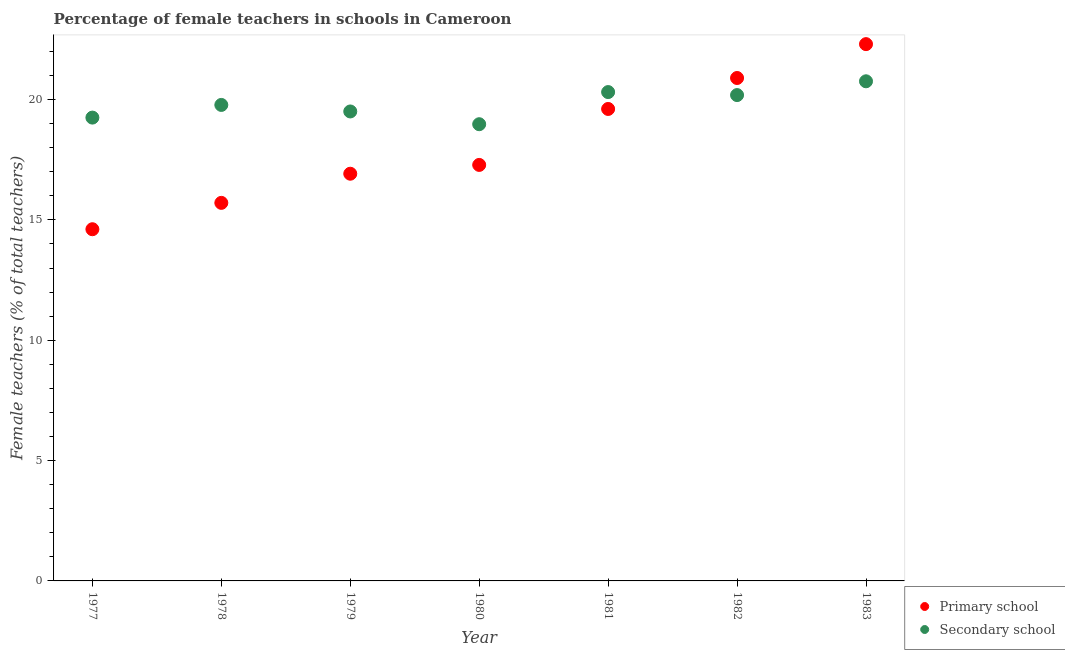How many different coloured dotlines are there?
Provide a short and direct response. 2. Is the number of dotlines equal to the number of legend labels?
Ensure brevity in your answer.  Yes. What is the percentage of female teachers in secondary schools in 1980?
Give a very brief answer. 18.98. Across all years, what is the maximum percentage of female teachers in secondary schools?
Provide a succinct answer. 20.76. Across all years, what is the minimum percentage of female teachers in primary schools?
Your answer should be compact. 14.61. What is the total percentage of female teachers in primary schools in the graph?
Offer a very short reply. 127.33. What is the difference between the percentage of female teachers in primary schools in 1977 and that in 1981?
Give a very brief answer. -5. What is the difference between the percentage of female teachers in primary schools in 1979 and the percentage of female teachers in secondary schools in 1978?
Your answer should be very brief. -2.86. What is the average percentage of female teachers in primary schools per year?
Offer a very short reply. 18.19. In the year 1978, what is the difference between the percentage of female teachers in primary schools and percentage of female teachers in secondary schools?
Make the answer very short. -4.07. In how many years, is the percentage of female teachers in primary schools greater than 7 %?
Offer a terse response. 7. What is the ratio of the percentage of female teachers in primary schools in 1978 to that in 1980?
Offer a terse response. 0.91. Is the percentage of female teachers in secondary schools in 1977 less than that in 1981?
Make the answer very short. Yes. Is the difference between the percentage of female teachers in primary schools in 1980 and 1982 greater than the difference between the percentage of female teachers in secondary schools in 1980 and 1982?
Make the answer very short. No. What is the difference between the highest and the second highest percentage of female teachers in secondary schools?
Ensure brevity in your answer.  0.45. What is the difference between the highest and the lowest percentage of female teachers in secondary schools?
Your response must be concise. 1.78. Is the sum of the percentage of female teachers in secondary schools in 1977 and 1980 greater than the maximum percentage of female teachers in primary schools across all years?
Keep it short and to the point. Yes. Is the percentage of female teachers in secondary schools strictly greater than the percentage of female teachers in primary schools over the years?
Ensure brevity in your answer.  No. Are the values on the major ticks of Y-axis written in scientific E-notation?
Offer a terse response. No. Does the graph contain grids?
Offer a terse response. No. Where does the legend appear in the graph?
Keep it short and to the point. Bottom right. What is the title of the graph?
Your answer should be compact. Percentage of female teachers in schools in Cameroon. What is the label or title of the Y-axis?
Your response must be concise. Female teachers (% of total teachers). What is the Female teachers (% of total teachers) in Primary school in 1977?
Your response must be concise. 14.61. What is the Female teachers (% of total teachers) in Secondary school in 1977?
Make the answer very short. 19.25. What is the Female teachers (% of total teachers) of Primary school in 1978?
Provide a succinct answer. 15.71. What is the Female teachers (% of total teachers) of Secondary school in 1978?
Offer a very short reply. 19.78. What is the Female teachers (% of total teachers) in Primary school in 1979?
Keep it short and to the point. 16.92. What is the Female teachers (% of total teachers) in Secondary school in 1979?
Keep it short and to the point. 19.51. What is the Female teachers (% of total teachers) of Primary school in 1980?
Offer a very short reply. 17.28. What is the Female teachers (% of total teachers) of Secondary school in 1980?
Give a very brief answer. 18.98. What is the Female teachers (% of total teachers) in Primary school in 1981?
Provide a succinct answer. 19.61. What is the Female teachers (% of total teachers) of Secondary school in 1981?
Offer a terse response. 20.31. What is the Female teachers (% of total teachers) of Primary school in 1982?
Give a very brief answer. 20.9. What is the Female teachers (% of total teachers) in Secondary school in 1982?
Your answer should be very brief. 20.19. What is the Female teachers (% of total teachers) in Primary school in 1983?
Offer a terse response. 22.3. What is the Female teachers (% of total teachers) in Secondary school in 1983?
Offer a very short reply. 20.76. Across all years, what is the maximum Female teachers (% of total teachers) of Primary school?
Give a very brief answer. 22.3. Across all years, what is the maximum Female teachers (% of total teachers) in Secondary school?
Provide a succinct answer. 20.76. Across all years, what is the minimum Female teachers (% of total teachers) of Primary school?
Your response must be concise. 14.61. Across all years, what is the minimum Female teachers (% of total teachers) of Secondary school?
Your answer should be very brief. 18.98. What is the total Female teachers (% of total teachers) of Primary school in the graph?
Provide a short and direct response. 127.33. What is the total Female teachers (% of total teachers) of Secondary school in the graph?
Give a very brief answer. 138.76. What is the difference between the Female teachers (% of total teachers) in Primary school in 1977 and that in 1978?
Ensure brevity in your answer.  -1.1. What is the difference between the Female teachers (% of total teachers) of Secondary school in 1977 and that in 1978?
Make the answer very short. -0.53. What is the difference between the Female teachers (% of total teachers) of Primary school in 1977 and that in 1979?
Keep it short and to the point. -2.31. What is the difference between the Female teachers (% of total teachers) of Secondary school in 1977 and that in 1979?
Offer a terse response. -0.26. What is the difference between the Female teachers (% of total teachers) of Primary school in 1977 and that in 1980?
Keep it short and to the point. -2.67. What is the difference between the Female teachers (% of total teachers) in Secondary school in 1977 and that in 1980?
Provide a succinct answer. 0.27. What is the difference between the Female teachers (% of total teachers) in Primary school in 1977 and that in 1981?
Offer a terse response. -5. What is the difference between the Female teachers (% of total teachers) in Secondary school in 1977 and that in 1981?
Your response must be concise. -1.06. What is the difference between the Female teachers (% of total teachers) in Primary school in 1977 and that in 1982?
Your answer should be compact. -6.28. What is the difference between the Female teachers (% of total teachers) of Secondary school in 1977 and that in 1982?
Your answer should be compact. -0.94. What is the difference between the Female teachers (% of total teachers) of Primary school in 1977 and that in 1983?
Offer a terse response. -7.69. What is the difference between the Female teachers (% of total teachers) of Secondary school in 1977 and that in 1983?
Your answer should be very brief. -1.51. What is the difference between the Female teachers (% of total teachers) in Primary school in 1978 and that in 1979?
Give a very brief answer. -1.21. What is the difference between the Female teachers (% of total teachers) of Secondary school in 1978 and that in 1979?
Your answer should be compact. 0.27. What is the difference between the Female teachers (% of total teachers) in Primary school in 1978 and that in 1980?
Give a very brief answer. -1.58. What is the difference between the Female teachers (% of total teachers) of Secondary school in 1978 and that in 1980?
Offer a terse response. 0.8. What is the difference between the Female teachers (% of total teachers) in Primary school in 1978 and that in 1981?
Make the answer very short. -3.9. What is the difference between the Female teachers (% of total teachers) of Secondary school in 1978 and that in 1981?
Your answer should be very brief. -0.53. What is the difference between the Female teachers (% of total teachers) of Primary school in 1978 and that in 1982?
Your answer should be compact. -5.19. What is the difference between the Female teachers (% of total teachers) in Secondary school in 1978 and that in 1982?
Ensure brevity in your answer.  -0.41. What is the difference between the Female teachers (% of total teachers) of Primary school in 1978 and that in 1983?
Provide a succinct answer. -6.6. What is the difference between the Female teachers (% of total teachers) of Secondary school in 1978 and that in 1983?
Your response must be concise. -0.98. What is the difference between the Female teachers (% of total teachers) of Primary school in 1979 and that in 1980?
Offer a very short reply. -0.37. What is the difference between the Female teachers (% of total teachers) in Secondary school in 1979 and that in 1980?
Make the answer very short. 0.53. What is the difference between the Female teachers (% of total teachers) of Primary school in 1979 and that in 1981?
Your answer should be very brief. -2.69. What is the difference between the Female teachers (% of total teachers) of Secondary school in 1979 and that in 1981?
Provide a succinct answer. -0.81. What is the difference between the Female teachers (% of total teachers) in Primary school in 1979 and that in 1982?
Offer a terse response. -3.98. What is the difference between the Female teachers (% of total teachers) of Secondary school in 1979 and that in 1982?
Offer a very short reply. -0.68. What is the difference between the Female teachers (% of total teachers) in Primary school in 1979 and that in 1983?
Offer a very short reply. -5.38. What is the difference between the Female teachers (% of total teachers) of Secondary school in 1979 and that in 1983?
Your answer should be very brief. -1.25. What is the difference between the Female teachers (% of total teachers) of Primary school in 1980 and that in 1981?
Your answer should be very brief. -2.33. What is the difference between the Female teachers (% of total teachers) of Secondary school in 1980 and that in 1981?
Your answer should be compact. -1.34. What is the difference between the Female teachers (% of total teachers) of Primary school in 1980 and that in 1982?
Offer a terse response. -3.61. What is the difference between the Female teachers (% of total teachers) of Secondary school in 1980 and that in 1982?
Keep it short and to the point. -1.21. What is the difference between the Female teachers (% of total teachers) of Primary school in 1980 and that in 1983?
Keep it short and to the point. -5.02. What is the difference between the Female teachers (% of total teachers) of Secondary school in 1980 and that in 1983?
Your response must be concise. -1.78. What is the difference between the Female teachers (% of total teachers) of Primary school in 1981 and that in 1982?
Your response must be concise. -1.29. What is the difference between the Female teachers (% of total teachers) of Secondary school in 1981 and that in 1982?
Ensure brevity in your answer.  0.12. What is the difference between the Female teachers (% of total teachers) of Primary school in 1981 and that in 1983?
Provide a succinct answer. -2.69. What is the difference between the Female teachers (% of total teachers) in Secondary school in 1981 and that in 1983?
Offer a terse response. -0.45. What is the difference between the Female teachers (% of total teachers) of Primary school in 1982 and that in 1983?
Keep it short and to the point. -1.41. What is the difference between the Female teachers (% of total teachers) in Secondary school in 1982 and that in 1983?
Provide a short and direct response. -0.57. What is the difference between the Female teachers (% of total teachers) in Primary school in 1977 and the Female teachers (% of total teachers) in Secondary school in 1978?
Keep it short and to the point. -5.16. What is the difference between the Female teachers (% of total teachers) of Primary school in 1977 and the Female teachers (% of total teachers) of Secondary school in 1979?
Provide a succinct answer. -4.89. What is the difference between the Female teachers (% of total teachers) in Primary school in 1977 and the Female teachers (% of total teachers) in Secondary school in 1980?
Offer a very short reply. -4.36. What is the difference between the Female teachers (% of total teachers) in Primary school in 1977 and the Female teachers (% of total teachers) in Secondary school in 1981?
Make the answer very short. -5.7. What is the difference between the Female teachers (% of total teachers) in Primary school in 1977 and the Female teachers (% of total teachers) in Secondary school in 1982?
Give a very brief answer. -5.57. What is the difference between the Female teachers (% of total teachers) of Primary school in 1977 and the Female teachers (% of total teachers) of Secondary school in 1983?
Offer a very short reply. -6.15. What is the difference between the Female teachers (% of total teachers) in Primary school in 1978 and the Female teachers (% of total teachers) in Secondary school in 1979?
Ensure brevity in your answer.  -3.8. What is the difference between the Female teachers (% of total teachers) in Primary school in 1978 and the Female teachers (% of total teachers) in Secondary school in 1980?
Your answer should be compact. -3.27. What is the difference between the Female teachers (% of total teachers) in Primary school in 1978 and the Female teachers (% of total teachers) in Secondary school in 1981?
Offer a terse response. -4.6. What is the difference between the Female teachers (% of total teachers) in Primary school in 1978 and the Female teachers (% of total teachers) in Secondary school in 1982?
Give a very brief answer. -4.48. What is the difference between the Female teachers (% of total teachers) of Primary school in 1978 and the Female teachers (% of total teachers) of Secondary school in 1983?
Your response must be concise. -5.05. What is the difference between the Female teachers (% of total teachers) in Primary school in 1979 and the Female teachers (% of total teachers) in Secondary school in 1980?
Provide a short and direct response. -2.06. What is the difference between the Female teachers (% of total teachers) in Primary school in 1979 and the Female teachers (% of total teachers) in Secondary school in 1981?
Give a very brief answer. -3.39. What is the difference between the Female teachers (% of total teachers) of Primary school in 1979 and the Female teachers (% of total teachers) of Secondary school in 1982?
Your answer should be very brief. -3.27. What is the difference between the Female teachers (% of total teachers) of Primary school in 1979 and the Female teachers (% of total teachers) of Secondary school in 1983?
Offer a very short reply. -3.84. What is the difference between the Female teachers (% of total teachers) of Primary school in 1980 and the Female teachers (% of total teachers) of Secondary school in 1981?
Keep it short and to the point. -3.03. What is the difference between the Female teachers (% of total teachers) of Primary school in 1980 and the Female teachers (% of total teachers) of Secondary school in 1982?
Provide a short and direct response. -2.9. What is the difference between the Female teachers (% of total teachers) of Primary school in 1980 and the Female teachers (% of total teachers) of Secondary school in 1983?
Your answer should be compact. -3.47. What is the difference between the Female teachers (% of total teachers) in Primary school in 1981 and the Female teachers (% of total teachers) in Secondary school in 1982?
Keep it short and to the point. -0.58. What is the difference between the Female teachers (% of total teachers) of Primary school in 1981 and the Female teachers (% of total teachers) of Secondary school in 1983?
Offer a very short reply. -1.15. What is the difference between the Female teachers (% of total teachers) of Primary school in 1982 and the Female teachers (% of total teachers) of Secondary school in 1983?
Offer a terse response. 0.14. What is the average Female teachers (% of total teachers) of Primary school per year?
Provide a short and direct response. 18.19. What is the average Female teachers (% of total teachers) of Secondary school per year?
Your response must be concise. 19.82. In the year 1977, what is the difference between the Female teachers (% of total teachers) in Primary school and Female teachers (% of total teachers) in Secondary school?
Your answer should be compact. -4.64. In the year 1978, what is the difference between the Female teachers (% of total teachers) of Primary school and Female teachers (% of total teachers) of Secondary school?
Give a very brief answer. -4.07. In the year 1979, what is the difference between the Female teachers (% of total teachers) in Primary school and Female teachers (% of total teachers) in Secondary school?
Make the answer very short. -2.59. In the year 1980, what is the difference between the Female teachers (% of total teachers) of Primary school and Female teachers (% of total teachers) of Secondary school?
Ensure brevity in your answer.  -1.69. In the year 1981, what is the difference between the Female teachers (% of total teachers) in Primary school and Female teachers (% of total teachers) in Secondary school?
Ensure brevity in your answer.  -0.7. In the year 1982, what is the difference between the Female teachers (% of total teachers) in Primary school and Female teachers (% of total teachers) in Secondary school?
Provide a short and direct response. 0.71. In the year 1983, what is the difference between the Female teachers (% of total teachers) in Primary school and Female teachers (% of total teachers) in Secondary school?
Your response must be concise. 1.54. What is the ratio of the Female teachers (% of total teachers) in Primary school in 1977 to that in 1978?
Ensure brevity in your answer.  0.93. What is the ratio of the Female teachers (% of total teachers) in Secondary school in 1977 to that in 1978?
Your answer should be very brief. 0.97. What is the ratio of the Female teachers (% of total teachers) in Primary school in 1977 to that in 1979?
Your answer should be compact. 0.86. What is the ratio of the Female teachers (% of total teachers) in Secondary school in 1977 to that in 1979?
Give a very brief answer. 0.99. What is the ratio of the Female teachers (% of total teachers) in Primary school in 1977 to that in 1980?
Provide a succinct answer. 0.85. What is the ratio of the Female teachers (% of total teachers) in Secondary school in 1977 to that in 1980?
Keep it short and to the point. 1.01. What is the ratio of the Female teachers (% of total teachers) of Primary school in 1977 to that in 1981?
Provide a short and direct response. 0.75. What is the ratio of the Female teachers (% of total teachers) in Secondary school in 1977 to that in 1981?
Ensure brevity in your answer.  0.95. What is the ratio of the Female teachers (% of total teachers) of Primary school in 1977 to that in 1982?
Provide a succinct answer. 0.7. What is the ratio of the Female teachers (% of total teachers) in Secondary school in 1977 to that in 1982?
Keep it short and to the point. 0.95. What is the ratio of the Female teachers (% of total teachers) in Primary school in 1977 to that in 1983?
Offer a very short reply. 0.66. What is the ratio of the Female teachers (% of total teachers) in Secondary school in 1977 to that in 1983?
Provide a succinct answer. 0.93. What is the ratio of the Female teachers (% of total teachers) in Primary school in 1978 to that in 1979?
Give a very brief answer. 0.93. What is the ratio of the Female teachers (% of total teachers) of Secondary school in 1978 to that in 1979?
Your response must be concise. 1.01. What is the ratio of the Female teachers (% of total teachers) in Primary school in 1978 to that in 1980?
Your response must be concise. 0.91. What is the ratio of the Female teachers (% of total teachers) in Secondary school in 1978 to that in 1980?
Your answer should be compact. 1.04. What is the ratio of the Female teachers (% of total teachers) of Primary school in 1978 to that in 1981?
Your response must be concise. 0.8. What is the ratio of the Female teachers (% of total teachers) in Secondary school in 1978 to that in 1981?
Offer a terse response. 0.97. What is the ratio of the Female teachers (% of total teachers) of Primary school in 1978 to that in 1982?
Your response must be concise. 0.75. What is the ratio of the Female teachers (% of total teachers) of Secondary school in 1978 to that in 1982?
Your answer should be compact. 0.98. What is the ratio of the Female teachers (% of total teachers) of Primary school in 1978 to that in 1983?
Offer a very short reply. 0.7. What is the ratio of the Female teachers (% of total teachers) of Secondary school in 1978 to that in 1983?
Your answer should be very brief. 0.95. What is the ratio of the Female teachers (% of total teachers) in Primary school in 1979 to that in 1980?
Offer a very short reply. 0.98. What is the ratio of the Female teachers (% of total teachers) of Secondary school in 1979 to that in 1980?
Your response must be concise. 1.03. What is the ratio of the Female teachers (% of total teachers) of Primary school in 1979 to that in 1981?
Ensure brevity in your answer.  0.86. What is the ratio of the Female teachers (% of total teachers) of Secondary school in 1979 to that in 1981?
Make the answer very short. 0.96. What is the ratio of the Female teachers (% of total teachers) in Primary school in 1979 to that in 1982?
Your answer should be compact. 0.81. What is the ratio of the Female teachers (% of total teachers) of Secondary school in 1979 to that in 1982?
Provide a short and direct response. 0.97. What is the ratio of the Female teachers (% of total teachers) of Primary school in 1979 to that in 1983?
Ensure brevity in your answer.  0.76. What is the ratio of the Female teachers (% of total teachers) in Secondary school in 1979 to that in 1983?
Ensure brevity in your answer.  0.94. What is the ratio of the Female teachers (% of total teachers) in Primary school in 1980 to that in 1981?
Ensure brevity in your answer.  0.88. What is the ratio of the Female teachers (% of total teachers) in Secondary school in 1980 to that in 1981?
Give a very brief answer. 0.93. What is the ratio of the Female teachers (% of total teachers) of Primary school in 1980 to that in 1982?
Make the answer very short. 0.83. What is the ratio of the Female teachers (% of total teachers) of Secondary school in 1980 to that in 1982?
Make the answer very short. 0.94. What is the ratio of the Female teachers (% of total teachers) of Primary school in 1980 to that in 1983?
Give a very brief answer. 0.78. What is the ratio of the Female teachers (% of total teachers) of Secondary school in 1980 to that in 1983?
Give a very brief answer. 0.91. What is the ratio of the Female teachers (% of total teachers) in Primary school in 1981 to that in 1982?
Provide a succinct answer. 0.94. What is the ratio of the Female teachers (% of total teachers) of Secondary school in 1981 to that in 1982?
Keep it short and to the point. 1.01. What is the ratio of the Female teachers (% of total teachers) in Primary school in 1981 to that in 1983?
Keep it short and to the point. 0.88. What is the ratio of the Female teachers (% of total teachers) of Secondary school in 1981 to that in 1983?
Make the answer very short. 0.98. What is the ratio of the Female teachers (% of total teachers) in Primary school in 1982 to that in 1983?
Provide a succinct answer. 0.94. What is the ratio of the Female teachers (% of total teachers) of Secondary school in 1982 to that in 1983?
Keep it short and to the point. 0.97. What is the difference between the highest and the second highest Female teachers (% of total teachers) of Primary school?
Your answer should be very brief. 1.41. What is the difference between the highest and the second highest Female teachers (% of total teachers) of Secondary school?
Your response must be concise. 0.45. What is the difference between the highest and the lowest Female teachers (% of total teachers) of Primary school?
Provide a short and direct response. 7.69. What is the difference between the highest and the lowest Female teachers (% of total teachers) of Secondary school?
Make the answer very short. 1.78. 